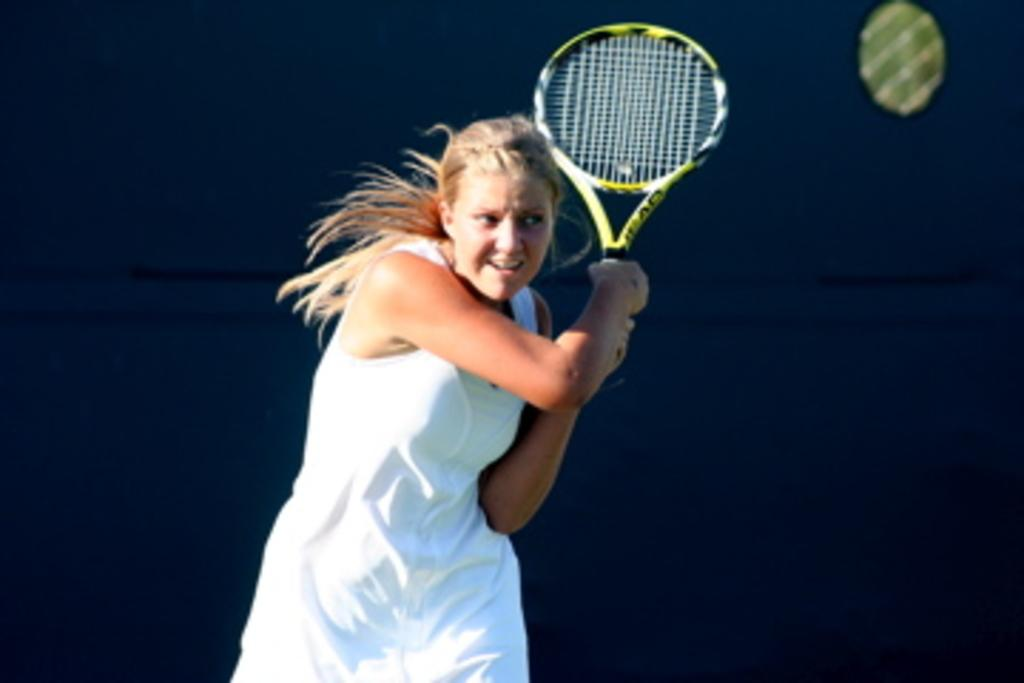What is the main subject of the image? There is a woman in the image. What activity is the woman engaged in? The woman is playing tennis. What type of bottle can be seen floating in the water near the woman? There is: There is no bottle or water present in the image; the woman is playing tennis on a tennis court. How many boats are visible in the image? There are no boats present in the image; the woman is playing tennis on a tennis court. 